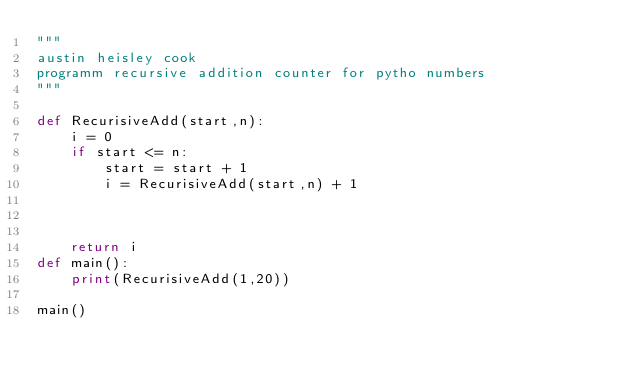Convert code to text. <code><loc_0><loc_0><loc_500><loc_500><_Python_>"""
austin heisley cook 
programm recursive addition counter for pytho numbers
"""

def RecurisiveAdd(start,n):
    i = 0
    if start <= n:
        start = start + 1 
        i = RecurisiveAdd(start,n) + 1
        
    
        
    return i
def main():
    print(RecurisiveAdd(1,20))

main()</code> 